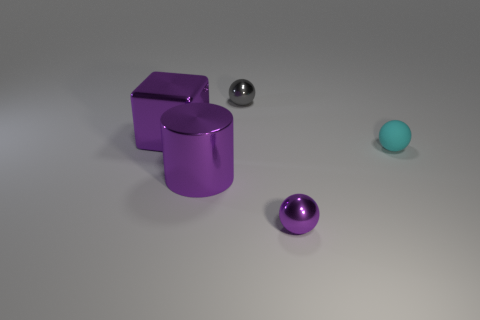There is a tiny sphere that is in front of the large purple thing that is right of the purple block; how many small gray shiny things are behind it?
Offer a terse response. 1. Is the number of small objects that are on the right side of the tiny purple object greater than the number of rubber things that are left of the cyan matte thing?
Give a very brief answer. Yes. What number of cyan shiny things are the same shape as the tiny gray object?
Your answer should be very brief. 0. What number of objects are shiny spheres behind the large block or big purple shiny objects in front of the purple metallic block?
Provide a succinct answer. 2. What material is the tiny purple ball that is in front of the tiny sphere that is to the left of the purple thing right of the gray metal object?
Keep it short and to the point. Metal. There is a small shiny ball that is to the right of the small gray metallic sphere; is its color the same as the matte sphere?
Keep it short and to the point. No. What material is the thing that is both behind the cyan matte ball and right of the shiny cylinder?
Provide a short and direct response. Metal. Is there a yellow sphere that has the same size as the cyan matte ball?
Your answer should be very brief. No. How many purple metallic objects are there?
Provide a short and direct response. 3. There is a small cyan matte object; what number of large purple shiny things are behind it?
Provide a succinct answer. 1. 